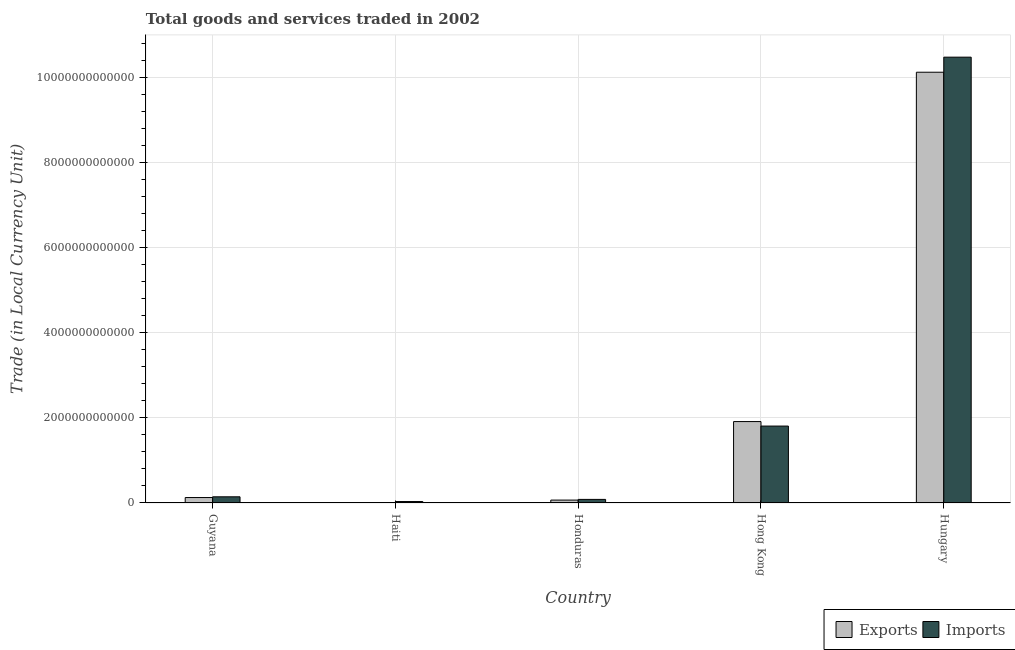How many groups of bars are there?
Offer a terse response. 5. Are the number of bars per tick equal to the number of legend labels?
Make the answer very short. Yes. How many bars are there on the 3rd tick from the left?
Your answer should be compact. 2. How many bars are there on the 3rd tick from the right?
Offer a terse response. 2. What is the label of the 2nd group of bars from the left?
Give a very brief answer. Haiti. In how many cases, is the number of bars for a given country not equal to the number of legend labels?
Keep it short and to the point. 0. What is the imports of goods and services in Honduras?
Provide a short and direct response. 8.43e+1. Across all countries, what is the maximum export of goods and services?
Ensure brevity in your answer.  1.01e+13. Across all countries, what is the minimum export of goods and services?
Keep it short and to the point. 1.14e+1. In which country was the export of goods and services maximum?
Your response must be concise. Hungary. In which country was the imports of goods and services minimum?
Provide a short and direct response. Haiti. What is the total imports of goods and services in the graph?
Provide a succinct answer. 1.25e+13. What is the difference between the export of goods and services in Honduras and that in Hungary?
Give a very brief answer. -1.00e+13. What is the difference between the export of goods and services in Guyana and the imports of goods and services in Hungary?
Ensure brevity in your answer.  -1.03e+13. What is the average export of goods and services per country?
Your response must be concise. 2.45e+12. What is the difference between the imports of goods and services and export of goods and services in Honduras?
Offer a terse response. 1.62e+1. What is the ratio of the export of goods and services in Haiti to that in Honduras?
Offer a very short reply. 0.17. Is the difference between the export of goods and services in Haiti and Hungary greater than the difference between the imports of goods and services in Haiti and Hungary?
Give a very brief answer. Yes. What is the difference between the highest and the second highest imports of goods and services?
Your answer should be very brief. 8.66e+12. What is the difference between the highest and the lowest imports of goods and services?
Keep it short and to the point. 1.04e+13. Is the sum of the imports of goods and services in Guyana and Hungary greater than the maximum export of goods and services across all countries?
Ensure brevity in your answer.  Yes. What does the 2nd bar from the left in Haiti represents?
Your response must be concise. Imports. What does the 1st bar from the right in Hong Kong represents?
Offer a very short reply. Imports. Are all the bars in the graph horizontal?
Keep it short and to the point. No. How many countries are there in the graph?
Ensure brevity in your answer.  5. What is the difference between two consecutive major ticks on the Y-axis?
Your answer should be very brief. 2.00e+12. Are the values on the major ticks of Y-axis written in scientific E-notation?
Make the answer very short. No. How are the legend labels stacked?
Ensure brevity in your answer.  Horizontal. What is the title of the graph?
Give a very brief answer. Total goods and services traded in 2002. What is the label or title of the X-axis?
Make the answer very short. Country. What is the label or title of the Y-axis?
Ensure brevity in your answer.  Trade (in Local Currency Unit). What is the Trade (in Local Currency Unit) of Exports in Guyana?
Provide a short and direct response. 1.28e+11. What is the Trade (in Local Currency Unit) in Imports in Guyana?
Provide a succinct answer. 1.45e+11. What is the Trade (in Local Currency Unit) in Exports in Haiti?
Provide a short and direct response. 1.14e+1. What is the Trade (in Local Currency Unit) of Imports in Haiti?
Offer a terse response. 3.39e+1. What is the Trade (in Local Currency Unit) of Exports in Honduras?
Offer a very short reply. 6.81e+1. What is the Trade (in Local Currency Unit) of Imports in Honduras?
Your answer should be very brief. 8.43e+1. What is the Trade (in Local Currency Unit) of Exports in Hong Kong?
Ensure brevity in your answer.  1.91e+12. What is the Trade (in Local Currency Unit) in Imports in Hong Kong?
Keep it short and to the point. 1.81e+12. What is the Trade (in Local Currency Unit) of Exports in Hungary?
Keep it short and to the point. 1.01e+13. What is the Trade (in Local Currency Unit) in Imports in Hungary?
Offer a very short reply. 1.05e+13. Across all countries, what is the maximum Trade (in Local Currency Unit) of Exports?
Offer a terse response. 1.01e+13. Across all countries, what is the maximum Trade (in Local Currency Unit) of Imports?
Provide a succinct answer. 1.05e+13. Across all countries, what is the minimum Trade (in Local Currency Unit) of Exports?
Offer a terse response. 1.14e+1. Across all countries, what is the minimum Trade (in Local Currency Unit) in Imports?
Provide a short and direct response. 3.39e+1. What is the total Trade (in Local Currency Unit) of Exports in the graph?
Offer a terse response. 1.22e+13. What is the total Trade (in Local Currency Unit) of Imports in the graph?
Keep it short and to the point. 1.25e+13. What is the difference between the Trade (in Local Currency Unit) in Exports in Guyana and that in Haiti?
Offer a terse response. 1.16e+11. What is the difference between the Trade (in Local Currency Unit) of Imports in Guyana and that in Haiti?
Make the answer very short. 1.11e+11. What is the difference between the Trade (in Local Currency Unit) of Exports in Guyana and that in Honduras?
Your answer should be very brief. 5.97e+1. What is the difference between the Trade (in Local Currency Unit) of Imports in Guyana and that in Honduras?
Your answer should be compact. 6.10e+1. What is the difference between the Trade (in Local Currency Unit) in Exports in Guyana and that in Hong Kong?
Keep it short and to the point. -1.78e+12. What is the difference between the Trade (in Local Currency Unit) of Imports in Guyana and that in Hong Kong?
Make the answer very short. -1.66e+12. What is the difference between the Trade (in Local Currency Unit) in Exports in Guyana and that in Hungary?
Provide a short and direct response. -9.99e+12. What is the difference between the Trade (in Local Currency Unit) in Imports in Guyana and that in Hungary?
Ensure brevity in your answer.  -1.03e+13. What is the difference between the Trade (in Local Currency Unit) in Exports in Haiti and that in Honduras?
Keep it short and to the point. -5.67e+1. What is the difference between the Trade (in Local Currency Unit) of Imports in Haiti and that in Honduras?
Give a very brief answer. -5.05e+1. What is the difference between the Trade (in Local Currency Unit) of Exports in Haiti and that in Hong Kong?
Provide a short and direct response. -1.90e+12. What is the difference between the Trade (in Local Currency Unit) of Imports in Haiti and that in Hong Kong?
Offer a terse response. -1.77e+12. What is the difference between the Trade (in Local Currency Unit) in Exports in Haiti and that in Hungary?
Make the answer very short. -1.01e+13. What is the difference between the Trade (in Local Currency Unit) in Imports in Haiti and that in Hungary?
Offer a very short reply. -1.04e+13. What is the difference between the Trade (in Local Currency Unit) of Exports in Honduras and that in Hong Kong?
Give a very brief answer. -1.84e+12. What is the difference between the Trade (in Local Currency Unit) of Imports in Honduras and that in Hong Kong?
Give a very brief answer. -1.72e+12. What is the difference between the Trade (in Local Currency Unit) of Exports in Honduras and that in Hungary?
Your answer should be compact. -1.00e+13. What is the difference between the Trade (in Local Currency Unit) of Imports in Honduras and that in Hungary?
Provide a short and direct response. -1.04e+13. What is the difference between the Trade (in Local Currency Unit) of Exports in Hong Kong and that in Hungary?
Your response must be concise. -8.20e+12. What is the difference between the Trade (in Local Currency Unit) in Imports in Hong Kong and that in Hungary?
Offer a terse response. -8.66e+12. What is the difference between the Trade (in Local Currency Unit) of Exports in Guyana and the Trade (in Local Currency Unit) of Imports in Haiti?
Provide a short and direct response. 9.39e+1. What is the difference between the Trade (in Local Currency Unit) of Exports in Guyana and the Trade (in Local Currency Unit) of Imports in Honduras?
Give a very brief answer. 4.35e+1. What is the difference between the Trade (in Local Currency Unit) in Exports in Guyana and the Trade (in Local Currency Unit) in Imports in Hong Kong?
Offer a terse response. -1.68e+12. What is the difference between the Trade (in Local Currency Unit) in Exports in Guyana and the Trade (in Local Currency Unit) in Imports in Hungary?
Give a very brief answer. -1.03e+13. What is the difference between the Trade (in Local Currency Unit) of Exports in Haiti and the Trade (in Local Currency Unit) of Imports in Honduras?
Offer a terse response. -7.29e+1. What is the difference between the Trade (in Local Currency Unit) in Exports in Haiti and the Trade (in Local Currency Unit) in Imports in Hong Kong?
Your answer should be compact. -1.79e+12. What is the difference between the Trade (in Local Currency Unit) in Exports in Haiti and the Trade (in Local Currency Unit) in Imports in Hungary?
Provide a short and direct response. -1.05e+13. What is the difference between the Trade (in Local Currency Unit) in Exports in Honduras and the Trade (in Local Currency Unit) in Imports in Hong Kong?
Your response must be concise. -1.74e+12. What is the difference between the Trade (in Local Currency Unit) of Exports in Honduras and the Trade (in Local Currency Unit) of Imports in Hungary?
Give a very brief answer. -1.04e+13. What is the difference between the Trade (in Local Currency Unit) in Exports in Hong Kong and the Trade (in Local Currency Unit) in Imports in Hungary?
Your response must be concise. -8.56e+12. What is the average Trade (in Local Currency Unit) in Exports per country?
Your answer should be compact. 2.45e+12. What is the average Trade (in Local Currency Unit) in Imports per country?
Make the answer very short. 2.51e+12. What is the difference between the Trade (in Local Currency Unit) of Exports and Trade (in Local Currency Unit) of Imports in Guyana?
Provide a short and direct response. -1.75e+1. What is the difference between the Trade (in Local Currency Unit) of Exports and Trade (in Local Currency Unit) of Imports in Haiti?
Provide a succinct answer. -2.24e+1. What is the difference between the Trade (in Local Currency Unit) in Exports and Trade (in Local Currency Unit) in Imports in Honduras?
Keep it short and to the point. -1.62e+1. What is the difference between the Trade (in Local Currency Unit) of Exports and Trade (in Local Currency Unit) of Imports in Hong Kong?
Ensure brevity in your answer.  1.06e+11. What is the difference between the Trade (in Local Currency Unit) of Exports and Trade (in Local Currency Unit) of Imports in Hungary?
Your answer should be compact. -3.54e+11. What is the ratio of the Trade (in Local Currency Unit) of Exports in Guyana to that in Haiti?
Make the answer very short. 11.21. What is the ratio of the Trade (in Local Currency Unit) of Imports in Guyana to that in Haiti?
Your answer should be compact. 4.29. What is the ratio of the Trade (in Local Currency Unit) of Exports in Guyana to that in Honduras?
Your answer should be compact. 1.88. What is the ratio of the Trade (in Local Currency Unit) in Imports in Guyana to that in Honduras?
Provide a succinct answer. 1.72. What is the ratio of the Trade (in Local Currency Unit) of Exports in Guyana to that in Hong Kong?
Your answer should be very brief. 0.07. What is the ratio of the Trade (in Local Currency Unit) of Imports in Guyana to that in Hong Kong?
Offer a very short reply. 0.08. What is the ratio of the Trade (in Local Currency Unit) in Exports in Guyana to that in Hungary?
Your answer should be compact. 0.01. What is the ratio of the Trade (in Local Currency Unit) in Imports in Guyana to that in Hungary?
Give a very brief answer. 0.01. What is the ratio of the Trade (in Local Currency Unit) in Exports in Haiti to that in Honduras?
Provide a succinct answer. 0.17. What is the ratio of the Trade (in Local Currency Unit) of Imports in Haiti to that in Honduras?
Your answer should be compact. 0.4. What is the ratio of the Trade (in Local Currency Unit) of Exports in Haiti to that in Hong Kong?
Make the answer very short. 0.01. What is the ratio of the Trade (in Local Currency Unit) of Imports in Haiti to that in Hong Kong?
Provide a short and direct response. 0.02. What is the ratio of the Trade (in Local Currency Unit) of Exports in Haiti to that in Hungary?
Your response must be concise. 0. What is the ratio of the Trade (in Local Currency Unit) of Imports in Haiti to that in Hungary?
Ensure brevity in your answer.  0. What is the ratio of the Trade (in Local Currency Unit) of Exports in Honduras to that in Hong Kong?
Give a very brief answer. 0.04. What is the ratio of the Trade (in Local Currency Unit) of Imports in Honduras to that in Hong Kong?
Offer a terse response. 0.05. What is the ratio of the Trade (in Local Currency Unit) in Exports in Honduras to that in Hungary?
Ensure brevity in your answer.  0.01. What is the ratio of the Trade (in Local Currency Unit) of Imports in Honduras to that in Hungary?
Provide a succinct answer. 0.01. What is the ratio of the Trade (in Local Currency Unit) in Exports in Hong Kong to that in Hungary?
Make the answer very short. 0.19. What is the ratio of the Trade (in Local Currency Unit) of Imports in Hong Kong to that in Hungary?
Provide a short and direct response. 0.17. What is the difference between the highest and the second highest Trade (in Local Currency Unit) of Exports?
Provide a succinct answer. 8.20e+12. What is the difference between the highest and the second highest Trade (in Local Currency Unit) of Imports?
Your answer should be very brief. 8.66e+12. What is the difference between the highest and the lowest Trade (in Local Currency Unit) of Exports?
Make the answer very short. 1.01e+13. What is the difference between the highest and the lowest Trade (in Local Currency Unit) in Imports?
Your answer should be compact. 1.04e+13. 